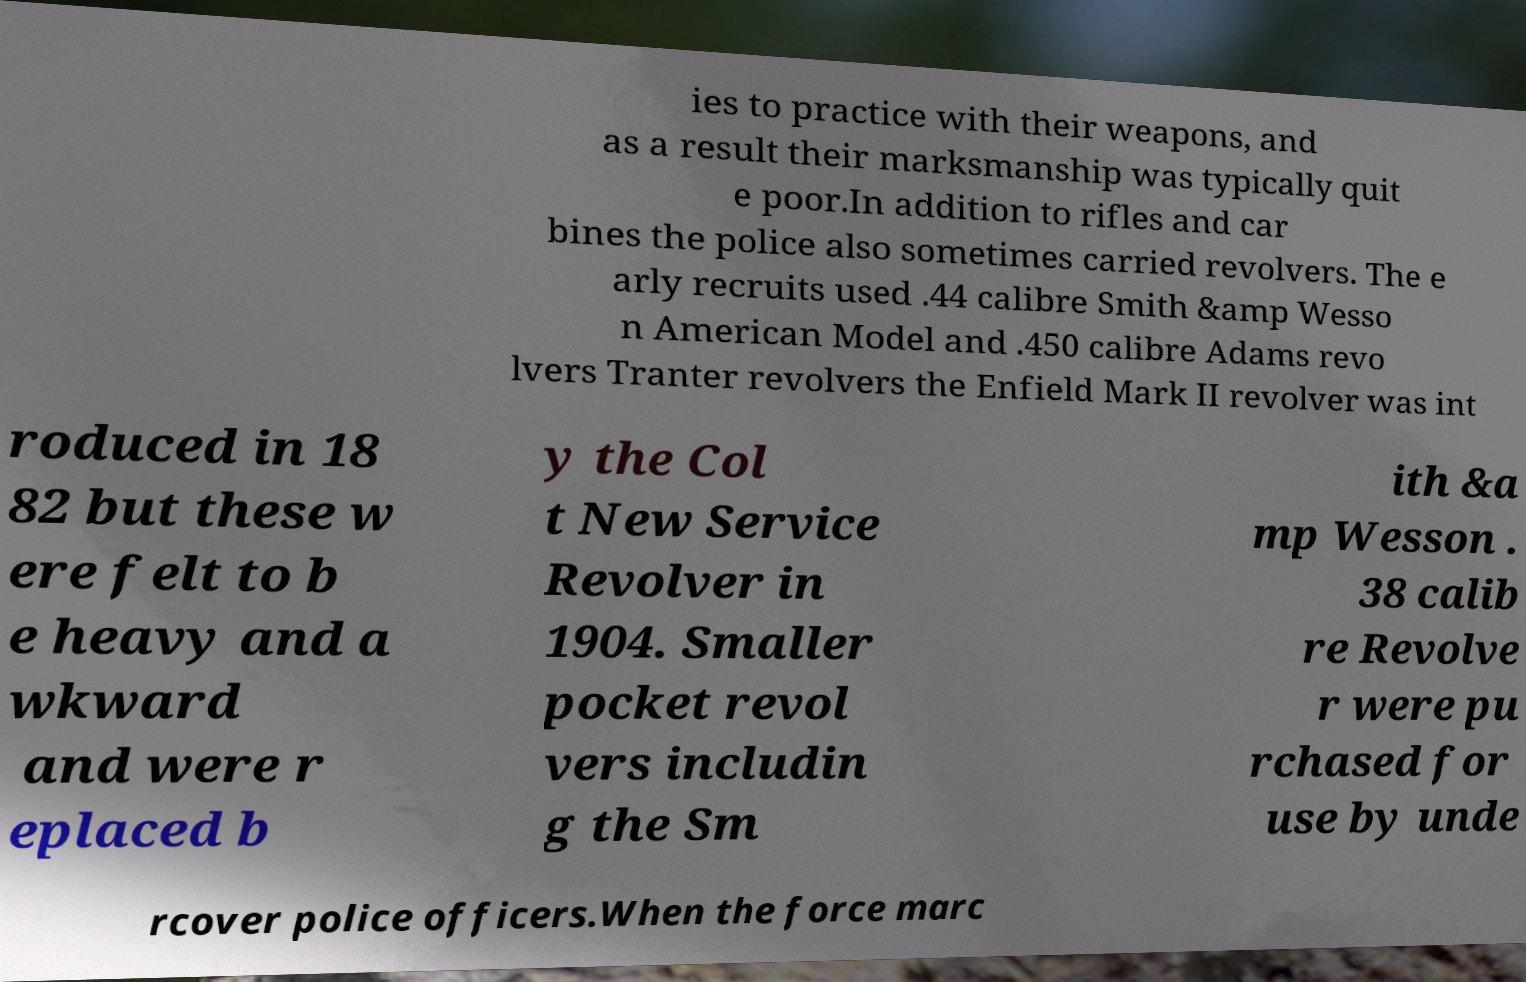Please identify and transcribe the text found in this image. ies to practice with their weapons, and as a result their marksmanship was typically quit e poor.In addition to rifles and car bines the police also sometimes carried revolvers. The e arly recruits used .44 calibre Smith &amp Wesso n American Model and .450 calibre Adams revo lvers Tranter revolvers the Enfield Mark II revolver was int roduced in 18 82 but these w ere felt to b e heavy and a wkward and were r eplaced b y the Col t New Service Revolver in 1904. Smaller pocket revol vers includin g the Sm ith &a mp Wesson . 38 calib re Revolve r were pu rchased for use by unde rcover police officers.When the force marc 